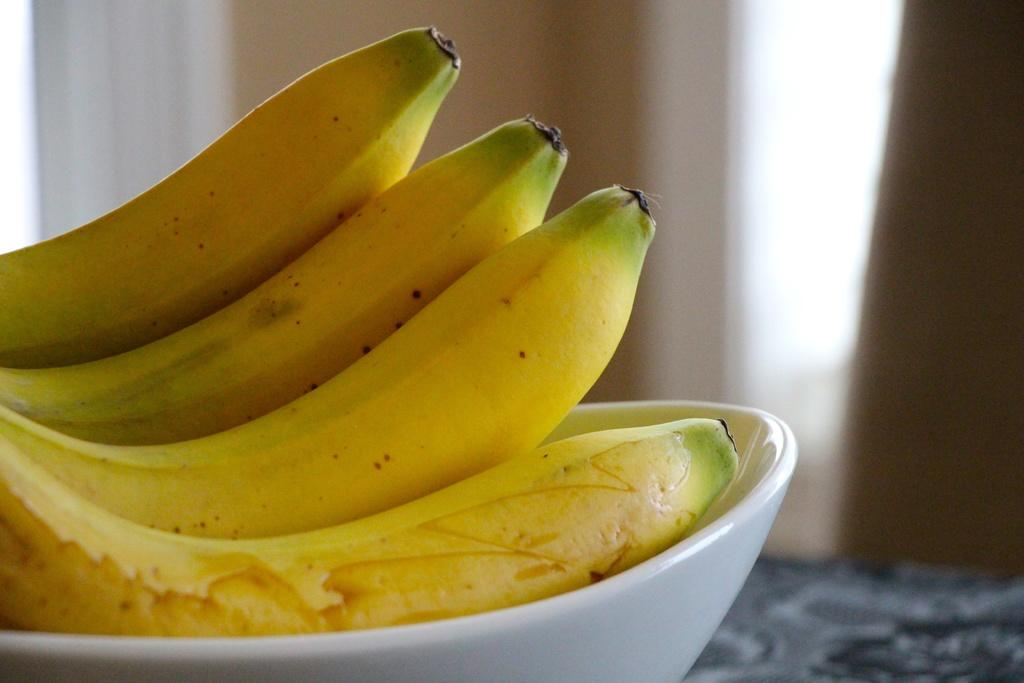What is the main object in the image? There is a table in the image. What is on top of the table? There is a bowl on the table. What is inside the bowl? There are bananas in the bowl. Can you describe the background of the image? The background of the image is blurred. What type of kite can be seen flying in the background of the image? There is no kite visible in the image; the background is blurred. Can you tell me how many cans are on the table in the image? There are no cans present on the table in the image; there is only a bowl with bananas. 